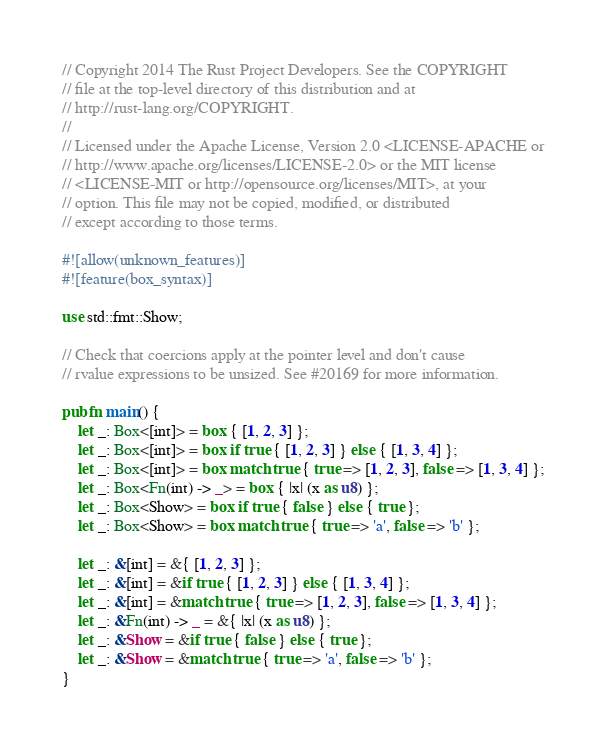Convert code to text. <code><loc_0><loc_0><loc_500><loc_500><_Rust_>// Copyright 2014 The Rust Project Developers. See the COPYRIGHT
// file at the top-level directory of this distribution and at
// http://rust-lang.org/COPYRIGHT.
//
// Licensed under the Apache License, Version 2.0 <LICENSE-APACHE or
// http://www.apache.org/licenses/LICENSE-2.0> or the MIT license
// <LICENSE-MIT or http://opensource.org/licenses/MIT>, at your
// option. This file may not be copied, modified, or distributed
// except according to those terms.

#![allow(unknown_features)]
#![feature(box_syntax)]

use std::fmt::Show;

// Check that coercions apply at the pointer level and don't cause
// rvalue expressions to be unsized. See #20169 for more information.

pub fn main() {
    let _: Box<[int]> = box { [1, 2, 3] };
    let _: Box<[int]> = box if true { [1, 2, 3] } else { [1, 3, 4] };
    let _: Box<[int]> = box match true { true => [1, 2, 3], false => [1, 3, 4] };
    let _: Box<Fn(int) -> _> = box { |x| (x as u8) };
    let _: Box<Show> = box if true { false } else { true };
    let _: Box<Show> = box match true { true => 'a', false => 'b' };

    let _: &[int] = &{ [1, 2, 3] };
    let _: &[int] = &if true { [1, 2, 3] } else { [1, 3, 4] };
    let _: &[int] = &match true { true => [1, 2, 3], false => [1, 3, 4] };
    let _: &Fn(int) -> _ = &{ |x| (x as u8) };
    let _: &Show = &if true { false } else { true };
    let _: &Show = &match true { true => 'a', false => 'b' };
}
</code> 